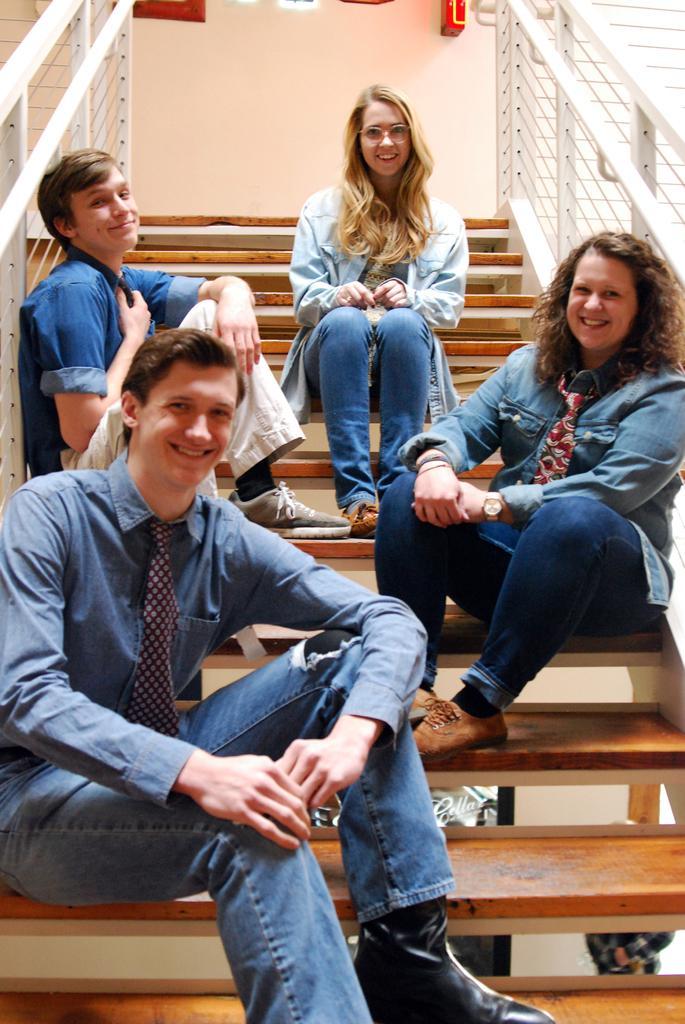How would you summarize this image in a sentence or two? In this image, I can see two women and two men sitting on the stairs and smiling. These are the staircase holders. These are the wooden stairs. This is the wall. 